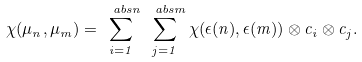<formula> <loc_0><loc_0><loc_500><loc_500>\chi ( \mu _ { n } , \mu _ { m } ) = \sum _ { i = 1 } ^ { \ a b s { n } } \sum _ { j = 1 } ^ { \ a b s { m } } \chi ( \epsilon ( n ) , \epsilon ( m ) ) \otimes c _ { i } \otimes c _ { j } .</formula> 